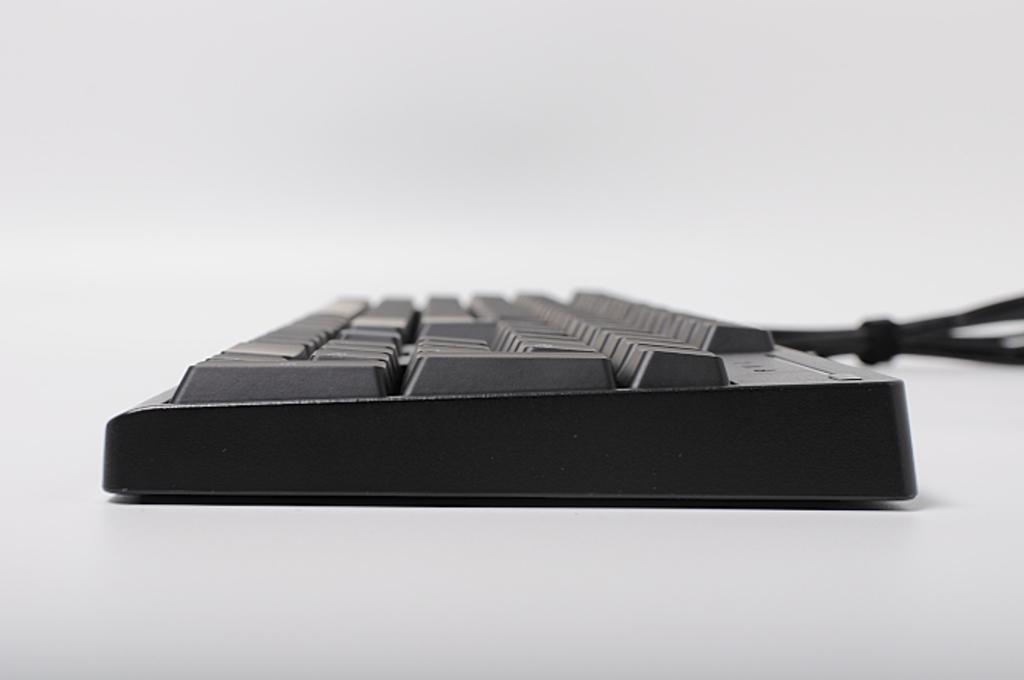Can you describe this image briefly? In this picture we can see a keyboard on a white surface. The background is blurred. 